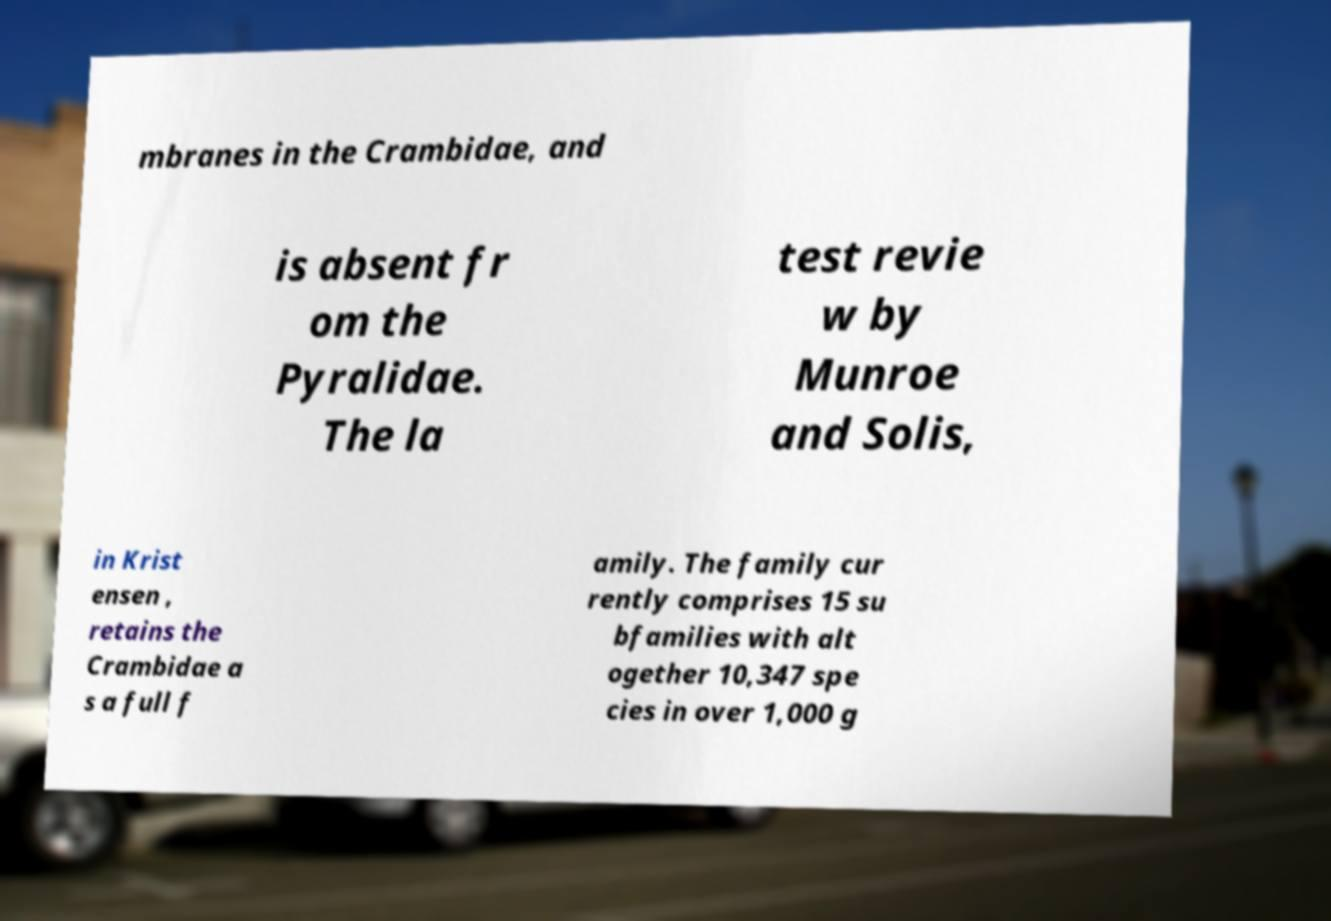Can you read and provide the text displayed in the image?This photo seems to have some interesting text. Can you extract and type it out for me? mbranes in the Crambidae, and is absent fr om the Pyralidae. The la test revie w by Munroe and Solis, in Krist ensen , retains the Crambidae a s a full f amily. The family cur rently comprises 15 su bfamilies with alt ogether 10,347 spe cies in over 1,000 g 